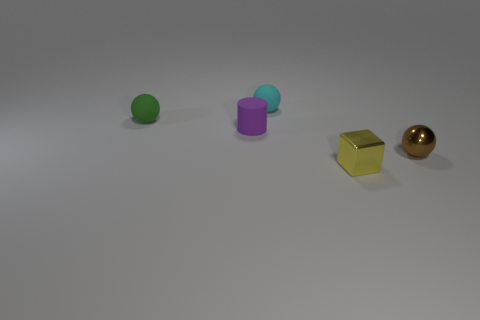Is there any indication of movement or stillness in the scene? The image gives an impression of stillness. There are no visible motion blurs or indications that the objects are in motion.  What textures can be observed on the objects? The surfaces of the objects appear smooth and reflective, indicating metallic or plastic materials. The sphere on the right shows clear reflectivity which suggests a polished finish. 